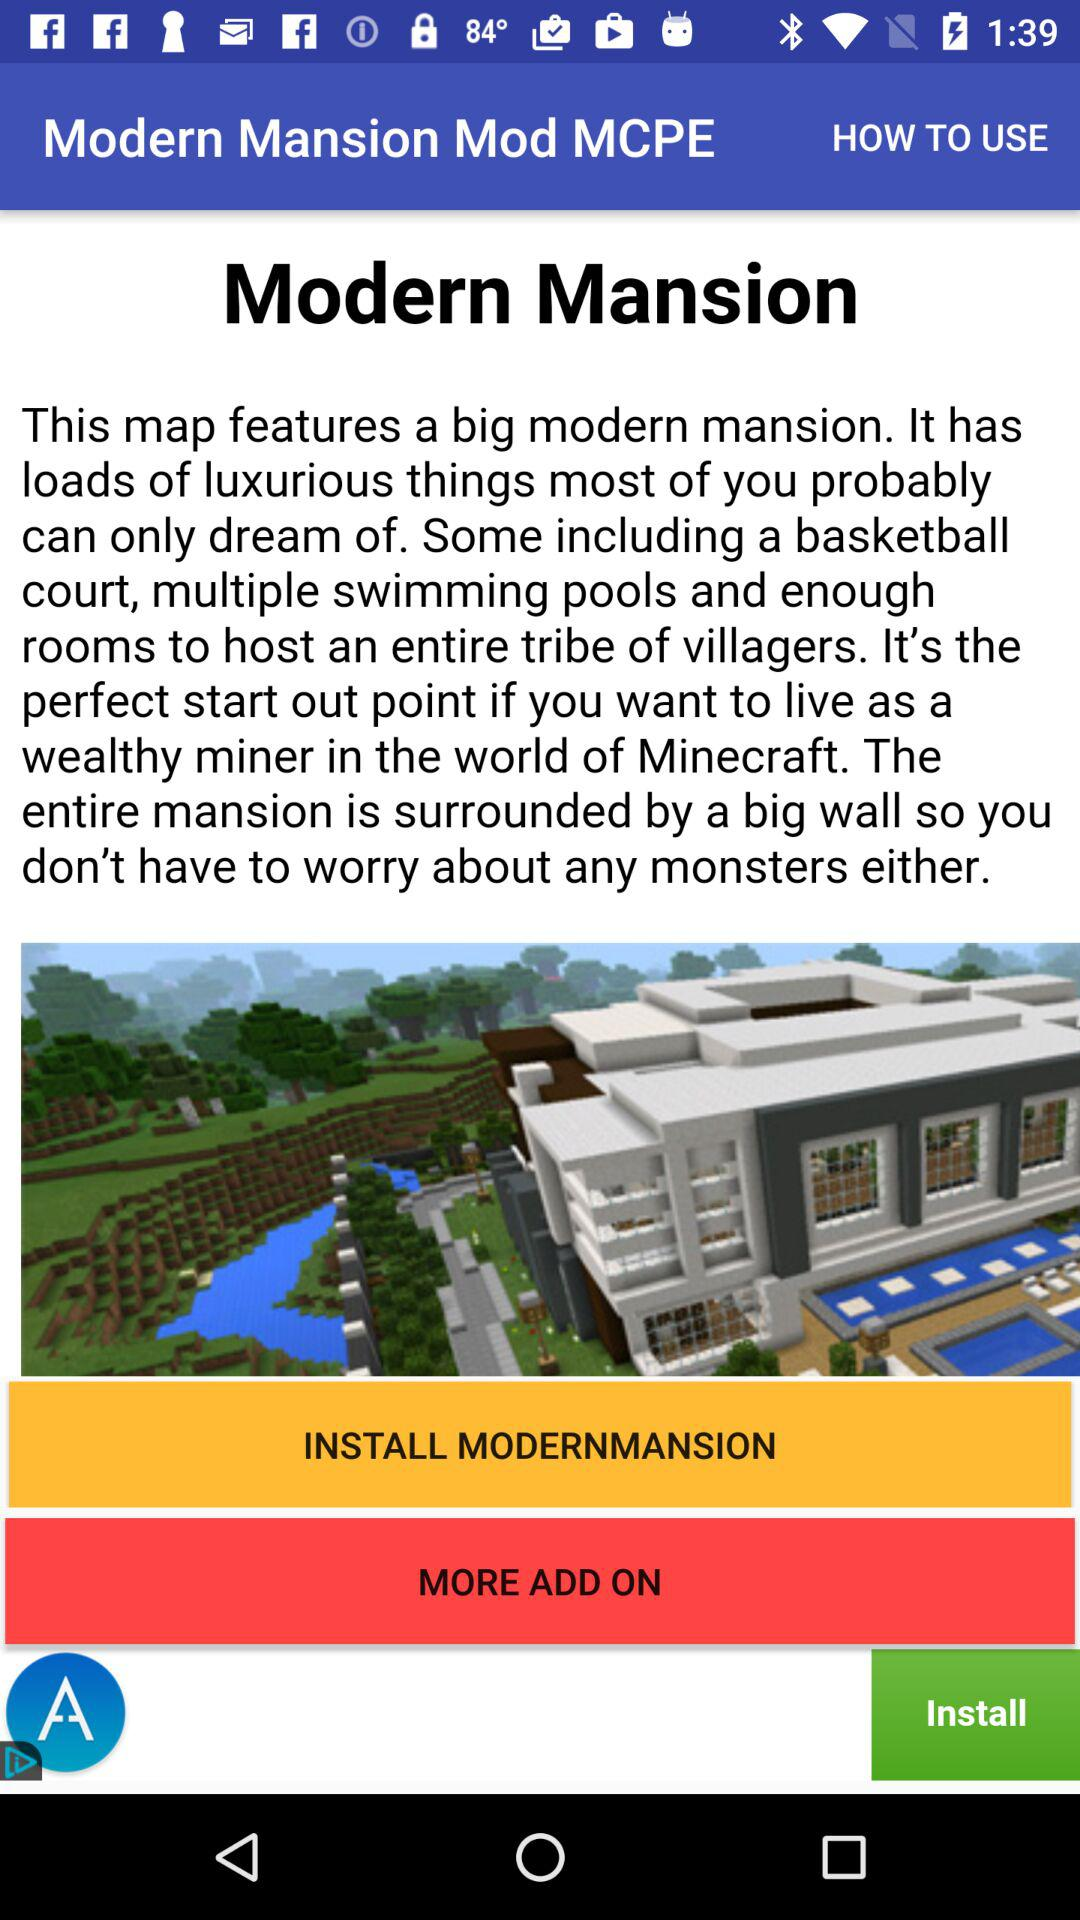What is the application name? The application name is "MODERNMANSION". 